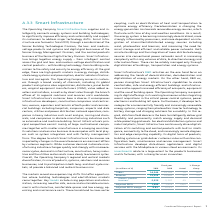According to Siemens Ag's financial document, What was the reason for the decline in the Adjusted EBITDA? Based on the financial document, the answer is Adjusted EBITA declined due mainly to the systems and software business including negative effects related to grid control projects early in the year.. Also, What drove the growth in the important building electrification and automation market? Based on the financial document, the answer is driven by demand for building performance and sustainability offerings, including strong demand for energy efficiency and digital services.. Also, If the new organizational structure had already existed in fiscal 2019, Smart Infrastructure would have posted what revenue in 2019?  Based on the financial document, the answer is € 14.597 billion. Also, can you calculate: What was the average orders for 2019 and 2018? To answer this question, I need to perform calculations using the financial data. The calculation is: (16,244 + 15,198) / 2, which equals 15721 (in millions). This is based on the information: "Orders 16,244 15,198 7 % 4 % Orders 16,244 15,198 7 % 4 %..." The key data points involved are: 15,198, 16,244. Also, can you calculate: What it the increase / (decrease) in revenue from 2018 to 2019? Based on the calculation: (15,225 - 14,445), the result is 780 (in millions). This is based on the information: "Revenue 15,225 14,445 5 % 3 % Revenue 15,225 14,445 5 % 3 %..." The key data points involved are: 14,445, 15,225. Also, can you calculate: What is the increase / (decrease) in the Adjusted EBITDA margin from 2018 to 2019? Based on the calculation: 9.9% - 10.9%, the result is -1 (percentage). This is based on the information: "Adjusted EBITA margin 9.9 % 10.9 % Adjusted EBITA margin 9.9 % 10.9 %..." The key data points involved are: 10.9, 9.9. 